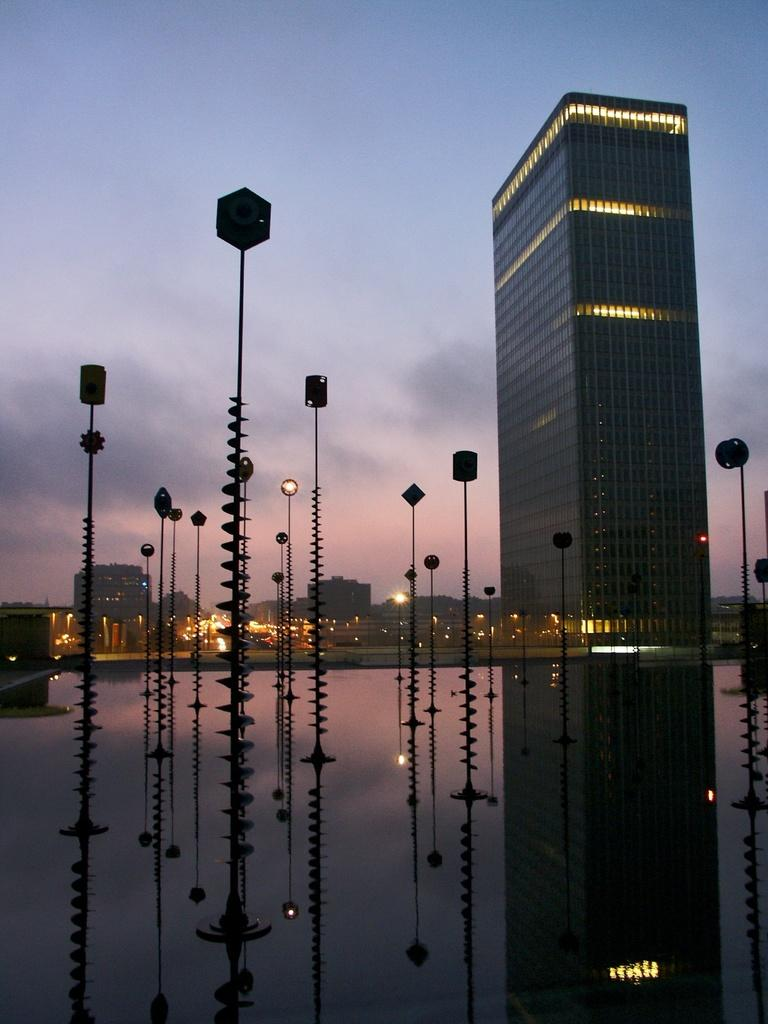What structures can be seen in the image? There are poles and buildings in the image. What type of illumination is present in the image? There are lights in the image. What can be seen in the background of the image? There are clouds and the sky visible in the background of the image. Are there any reflections in the image? Yes, there is a reflection of the poles in the image. What type of jar is visible on the mountain in the image? There is no mountain or jar present in the image. What type of vacation is being depicted in the image? The image does not depict a vacation; it shows poles, buildings, lights, clouds, sky, and a reflection of the poles. 